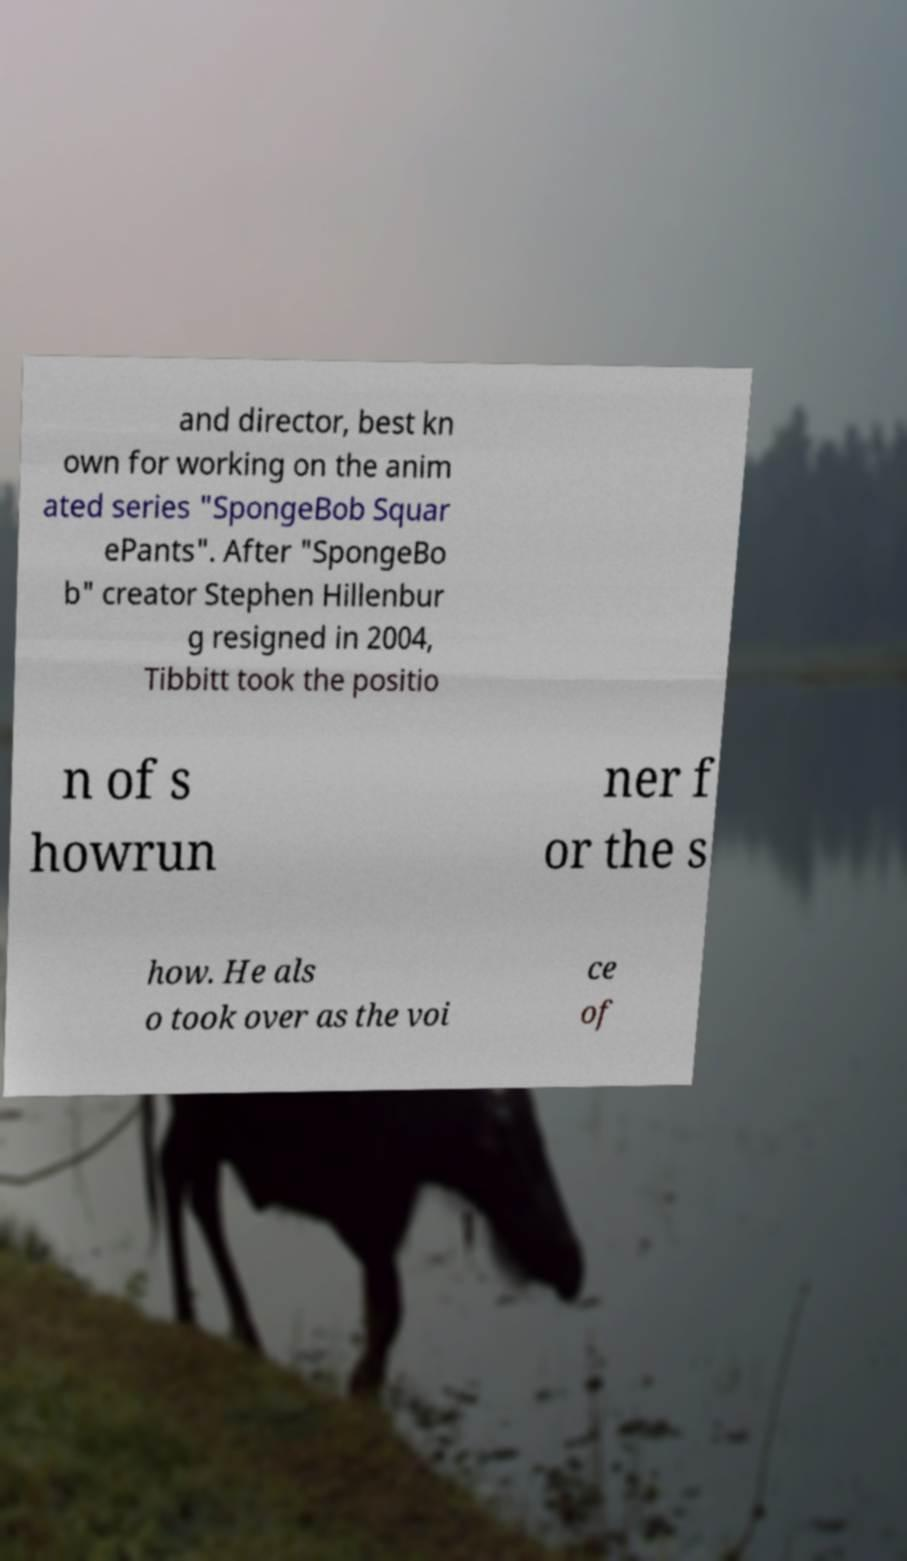Please read and relay the text visible in this image. What does it say? and director, best kn own for working on the anim ated series "SpongeBob Squar ePants". After "SpongeBo b" creator Stephen Hillenbur g resigned in 2004, Tibbitt took the positio n of s howrun ner f or the s how. He als o took over as the voi ce of 